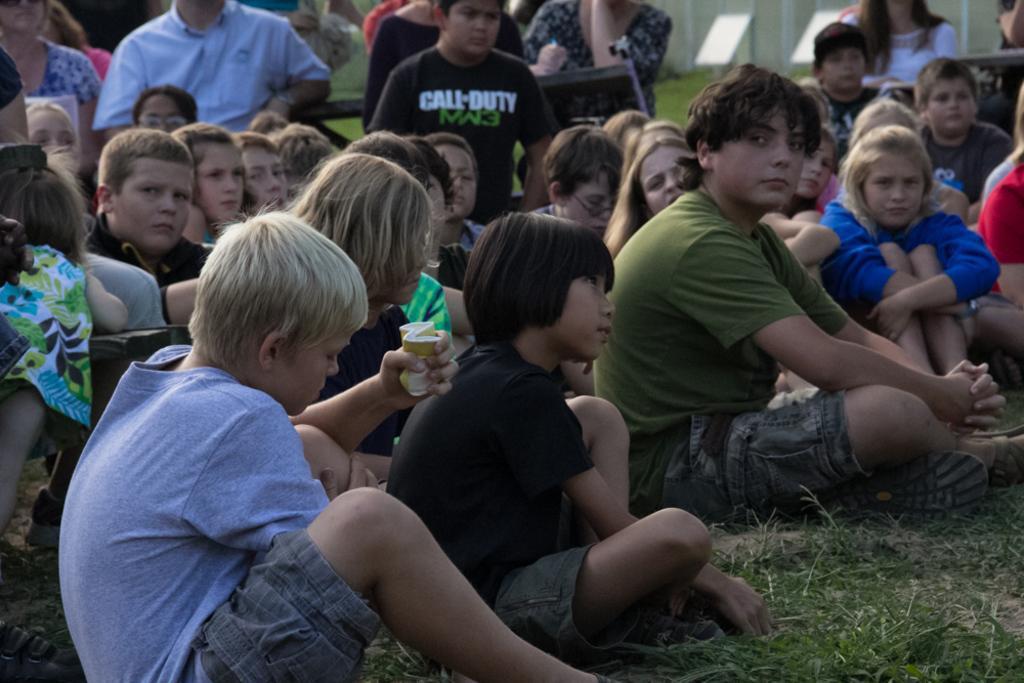Can you describe this image briefly? In this image there are group of persons sitting and there's grass on the ground. In the background there are boards and there is a wall. 